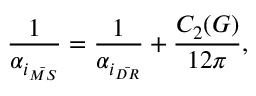Convert formula to latex. <formula><loc_0><loc_0><loc_500><loc_500>\frac { 1 } { \alpha _ { i _ { \bar { M S } } } } = \frac { 1 } { \alpha _ { i _ { \bar { D R } } } } + \frac { C _ { 2 } ( G ) } { 1 2 \pi } ,</formula> 